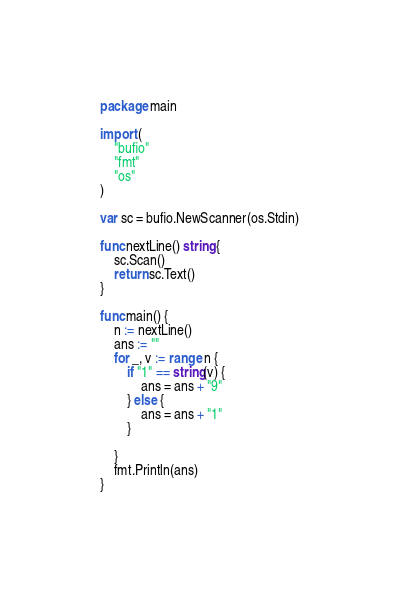Convert code to text. <code><loc_0><loc_0><loc_500><loc_500><_Go_>package main

import (
	"bufio"
	"fmt"
	"os"
)

var sc = bufio.NewScanner(os.Stdin)

func nextLine() string {
	sc.Scan()
	return sc.Text()
}

func main() {
	n := nextLine()
	ans := ""
	for _, v := range n {
		if "1" == string(v) {
			ans = ans + "9"
		} else {
			ans = ans + "1"
		}

	}
	fmt.Println(ans)
}
</code> 